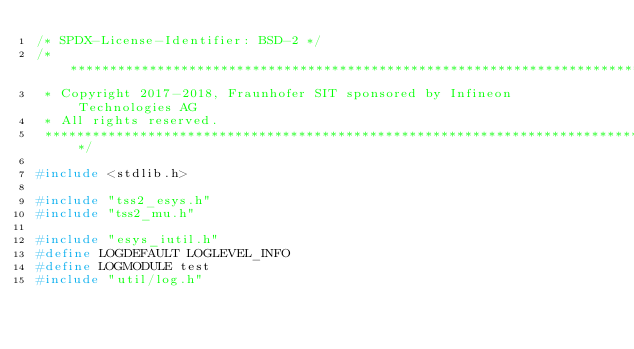<code> <loc_0><loc_0><loc_500><loc_500><_C_>/* SPDX-License-Identifier: BSD-2 */
/*******************************************************************************
 * Copyright 2017-2018, Fraunhofer SIT sponsored by Infineon Technologies AG
 * All rights reserved.
 *******************************************************************************/

#include <stdlib.h>

#include "tss2_esys.h"
#include "tss2_mu.h"

#include "esys_iutil.h"
#define LOGDEFAULT LOGLEVEL_INFO
#define LOGMODULE test
#include "util/log.h"</code> 